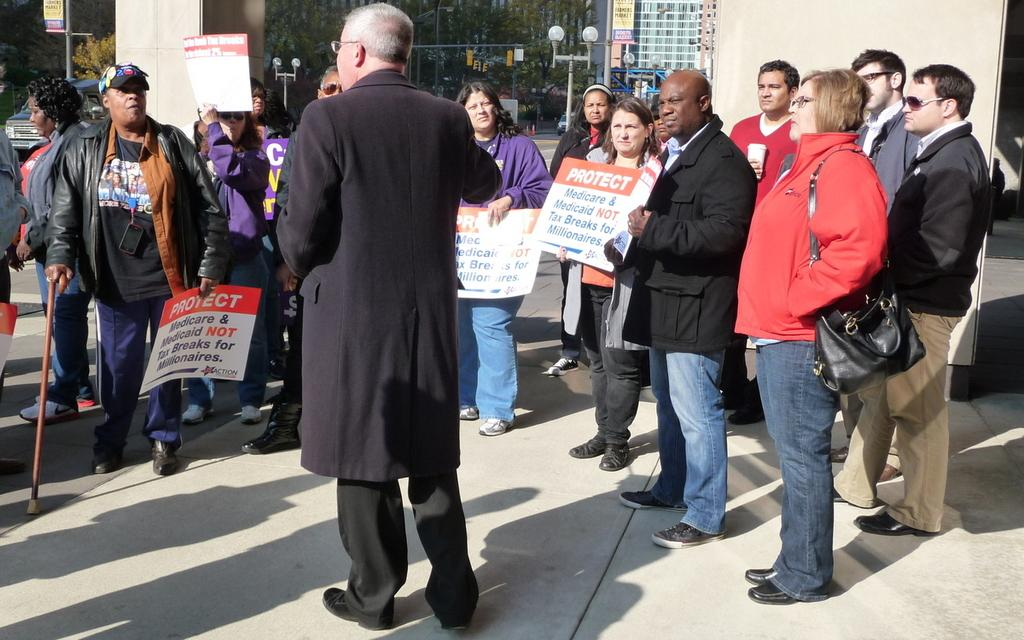What is the person in the image wearing? The person in the image is wearing a black coat. What is the person doing in the image? The person is standing and speaking to people in front of them. What are the people in front of the person holding? The people in front of the person are holding banners. Can you see any stars in the image? There are no stars visible in the image. Is there a dock present in the image? There is no dock present in the image. 